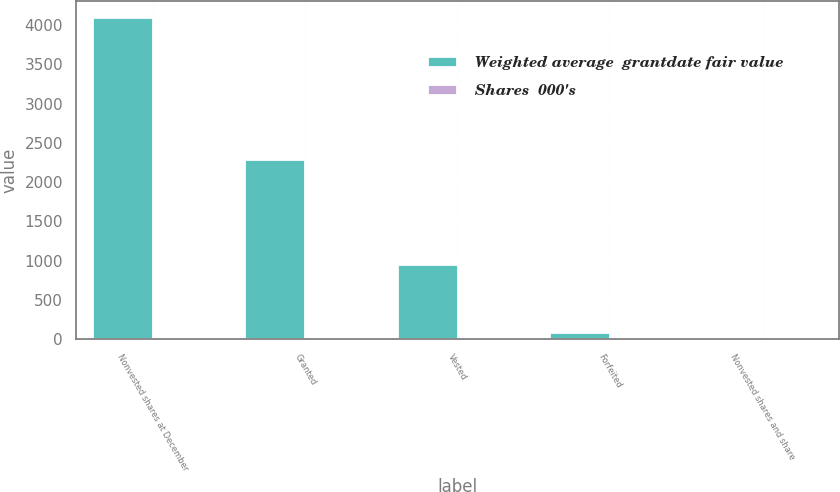Convert chart to OTSL. <chart><loc_0><loc_0><loc_500><loc_500><stacked_bar_chart><ecel><fcel>Nonvested shares at December<fcel>Granted<fcel>Vested<fcel>Forfeited<fcel>Nonvested shares and share<nl><fcel>Weighted average  grantdate fair value<fcel>4104<fcel>2299<fcel>951<fcel>89<fcel>18.19<nl><fcel>Shares  000's<fcel>18.16<fcel>13<fcel>18.19<fcel>16.25<fcel>15.97<nl></chart> 